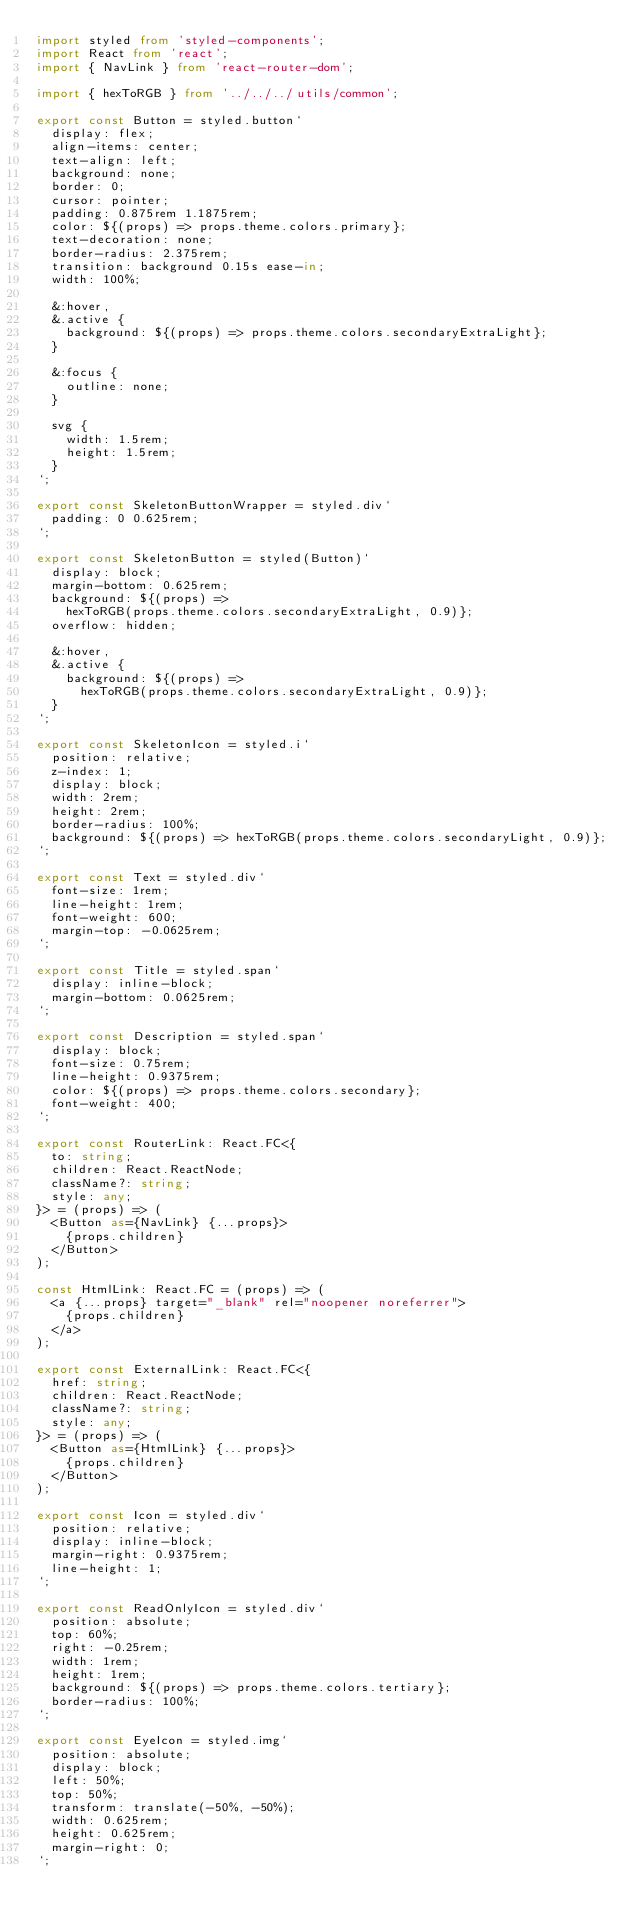Convert code to text. <code><loc_0><loc_0><loc_500><loc_500><_TypeScript_>import styled from 'styled-components';
import React from 'react';
import { NavLink } from 'react-router-dom';

import { hexToRGB } from '../../../utils/common';

export const Button = styled.button`
  display: flex;
  align-items: center;
  text-align: left;
  background: none;
  border: 0;
  cursor: pointer;
  padding: 0.875rem 1.1875rem;
  color: ${(props) => props.theme.colors.primary};
  text-decoration: none;
  border-radius: 2.375rem;
  transition: background 0.15s ease-in;
  width: 100%;

  &:hover,
  &.active {
    background: ${(props) => props.theme.colors.secondaryExtraLight};
  }

  &:focus {
    outline: none;
  }

  svg {
    width: 1.5rem;
    height: 1.5rem;
  }
`;

export const SkeletonButtonWrapper = styled.div`
  padding: 0 0.625rem;
`;

export const SkeletonButton = styled(Button)`
  display: block;
  margin-bottom: 0.625rem;
  background: ${(props) =>
    hexToRGB(props.theme.colors.secondaryExtraLight, 0.9)};
  overflow: hidden;

  &:hover,
  &.active {
    background: ${(props) =>
      hexToRGB(props.theme.colors.secondaryExtraLight, 0.9)};
  }
`;

export const SkeletonIcon = styled.i`
  position: relative;
  z-index: 1;
  display: block;
  width: 2rem;
  height: 2rem;
  border-radius: 100%;
  background: ${(props) => hexToRGB(props.theme.colors.secondaryLight, 0.9)};
`;

export const Text = styled.div`
  font-size: 1rem;
  line-height: 1rem;
  font-weight: 600;
  margin-top: -0.0625rem;
`;

export const Title = styled.span`
  display: inline-block;
  margin-bottom: 0.0625rem;
`;

export const Description = styled.span`
  display: block;
  font-size: 0.75rem;
  line-height: 0.9375rem;
  color: ${(props) => props.theme.colors.secondary};
  font-weight: 400;
`;

export const RouterLink: React.FC<{
  to: string;
  children: React.ReactNode;
  className?: string;
  style: any;
}> = (props) => (
  <Button as={NavLink} {...props}>
    {props.children}
  </Button>
);

const HtmlLink: React.FC = (props) => (
  <a {...props} target="_blank" rel="noopener noreferrer">
    {props.children}
  </a>
);

export const ExternalLink: React.FC<{
  href: string;
  children: React.ReactNode;
  className?: string;
  style: any;
}> = (props) => (
  <Button as={HtmlLink} {...props}>
    {props.children}
  </Button>
);

export const Icon = styled.div`
  position: relative;
  display: inline-block;
  margin-right: 0.9375rem;
  line-height: 1;
`;

export const ReadOnlyIcon = styled.div`
  position: absolute;
  top: 60%;
  right: -0.25rem;
  width: 1rem;
  height: 1rem;
  background: ${(props) => props.theme.colors.tertiary};
  border-radius: 100%;
`;

export const EyeIcon = styled.img`
  position: absolute;
  display: block;
  left: 50%;
  top: 50%;
  transform: translate(-50%, -50%);
  width: 0.625rem;
  height: 0.625rem;
  margin-right: 0;
`;
</code> 